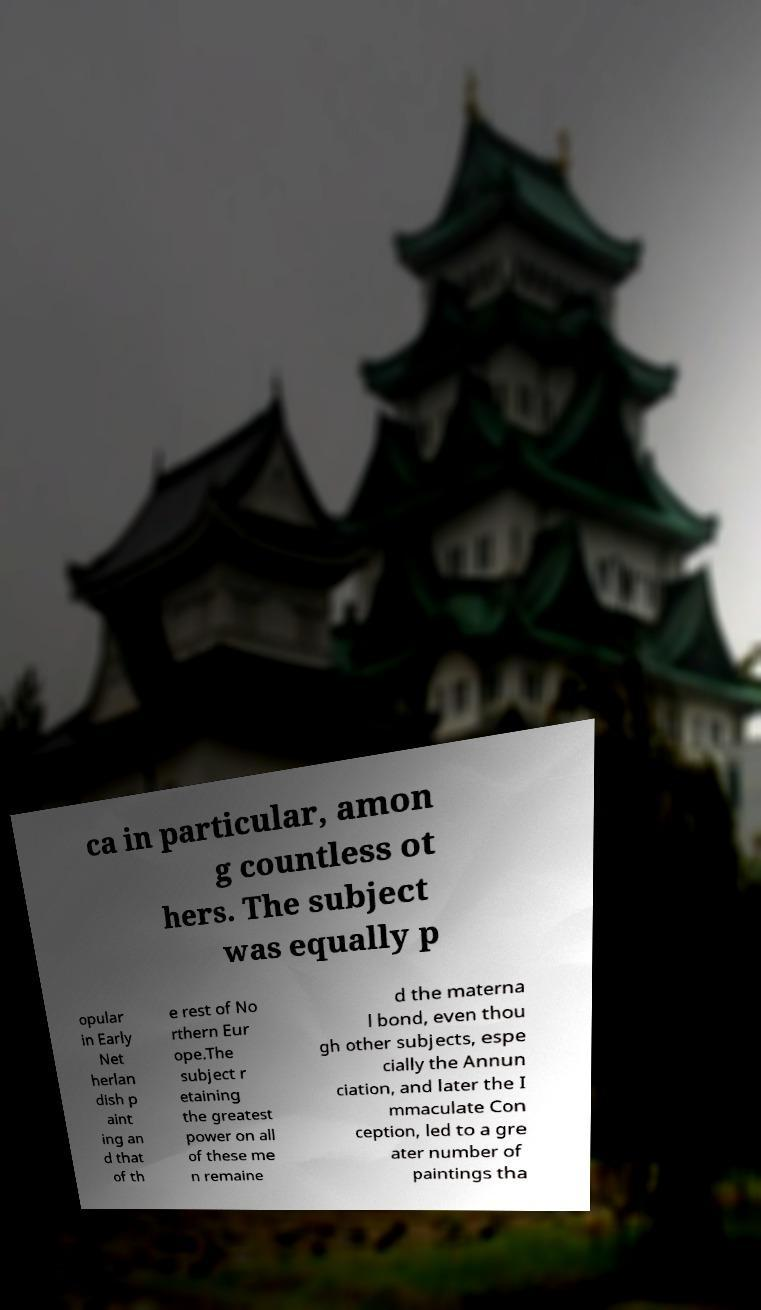I need the written content from this picture converted into text. Can you do that? ca in particular, amon g countless ot hers. The subject was equally p opular in Early Net herlan dish p aint ing an d that of th e rest of No rthern Eur ope.The subject r etaining the greatest power on all of these me n remaine d the materna l bond, even thou gh other subjects, espe cially the Annun ciation, and later the I mmaculate Con ception, led to a gre ater number of paintings tha 